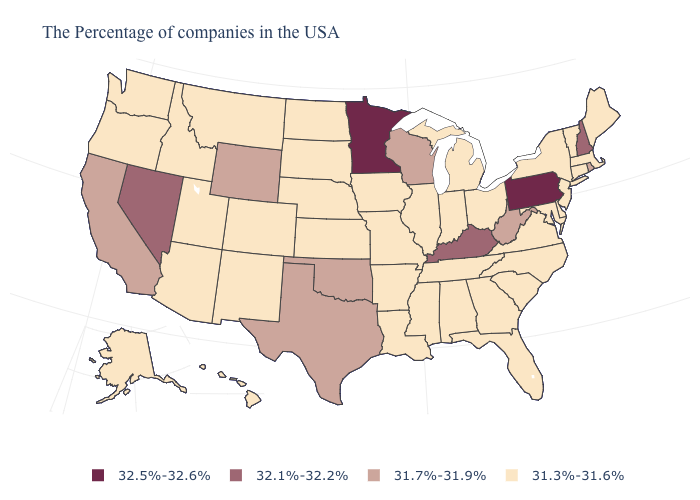Is the legend a continuous bar?
Short answer required. No. How many symbols are there in the legend?
Concise answer only. 4. How many symbols are there in the legend?
Write a very short answer. 4. Does Illinois have the highest value in the MidWest?
Quick response, please. No. How many symbols are there in the legend?
Write a very short answer. 4. Among the states that border Pennsylvania , which have the lowest value?
Quick response, please. New York, New Jersey, Delaware, Maryland, Ohio. Does Pennsylvania have the highest value in the Northeast?
Answer briefly. Yes. Name the states that have a value in the range 31.3%-31.6%?
Keep it brief. Maine, Massachusetts, Vermont, Connecticut, New York, New Jersey, Delaware, Maryland, Virginia, North Carolina, South Carolina, Ohio, Florida, Georgia, Michigan, Indiana, Alabama, Tennessee, Illinois, Mississippi, Louisiana, Missouri, Arkansas, Iowa, Kansas, Nebraska, South Dakota, North Dakota, Colorado, New Mexico, Utah, Montana, Arizona, Idaho, Washington, Oregon, Alaska, Hawaii. Does California have the lowest value in the West?
Write a very short answer. No. What is the highest value in the USA?
Answer briefly. 32.5%-32.6%. Does the map have missing data?
Answer briefly. No. Which states have the highest value in the USA?
Give a very brief answer. Pennsylvania, Minnesota. What is the value of Alabama?
Short answer required. 31.3%-31.6%. What is the highest value in states that border New Hampshire?
Keep it brief. 31.3%-31.6%. Among the states that border Maine , which have the highest value?
Concise answer only. New Hampshire. 